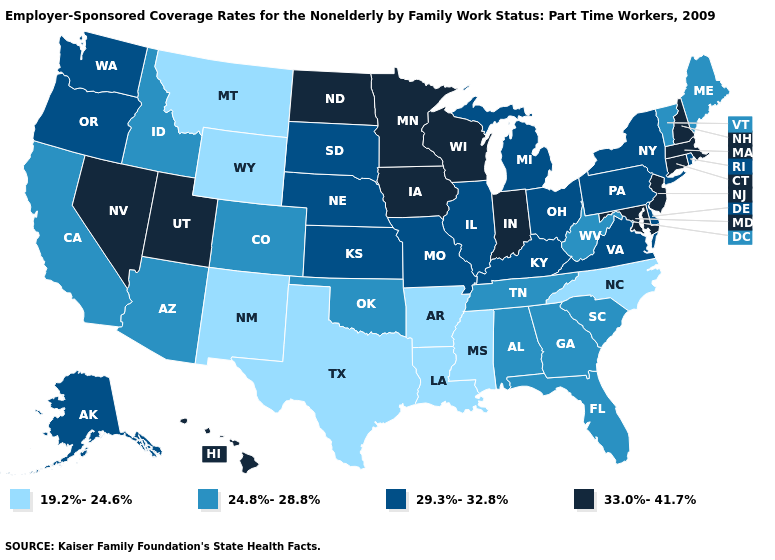Among the states that border Utah , does Nevada have the lowest value?
Quick response, please. No. Name the states that have a value in the range 19.2%-24.6%?
Quick response, please. Arkansas, Louisiana, Mississippi, Montana, New Mexico, North Carolina, Texas, Wyoming. What is the value of Maine?
Keep it brief. 24.8%-28.8%. Does the first symbol in the legend represent the smallest category?
Answer briefly. Yes. Which states have the highest value in the USA?
Be succinct. Connecticut, Hawaii, Indiana, Iowa, Maryland, Massachusetts, Minnesota, Nevada, New Hampshire, New Jersey, North Dakota, Utah, Wisconsin. Among the states that border Illinois , which have the highest value?
Give a very brief answer. Indiana, Iowa, Wisconsin. Name the states that have a value in the range 19.2%-24.6%?
Short answer required. Arkansas, Louisiana, Mississippi, Montana, New Mexico, North Carolina, Texas, Wyoming. Name the states that have a value in the range 19.2%-24.6%?
Quick response, please. Arkansas, Louisiana, Mississippi, Montana, New Mexico, North Carolina, Texas, Wyoming. Does the map have missing data?
Keep it brief. No. Among the states that border Arizona , which have the lowest value?
Keep it brief. New Mexico. How many symbols are there in the legend?
Short answer required. 4. What is the lowest value in the MidWest?
Concise answer only. 29.3%-32.8%. What is the value of New York?
Answer briefly. 29.3%-32.8%. What is the value of North Dakota?
Keep it brief. 33.0%-41.7%. Name the states that have a value in the range 29.3%-32.8%?
Keep it brief. Alaska, Delaware, Illinois, Kansas, Kentucky, Michigan, Missouri, Nebraska, New York, Ohio, Oregon, Pennsylvania, Rhode Island, South Dakota, Virginia, Washington. 